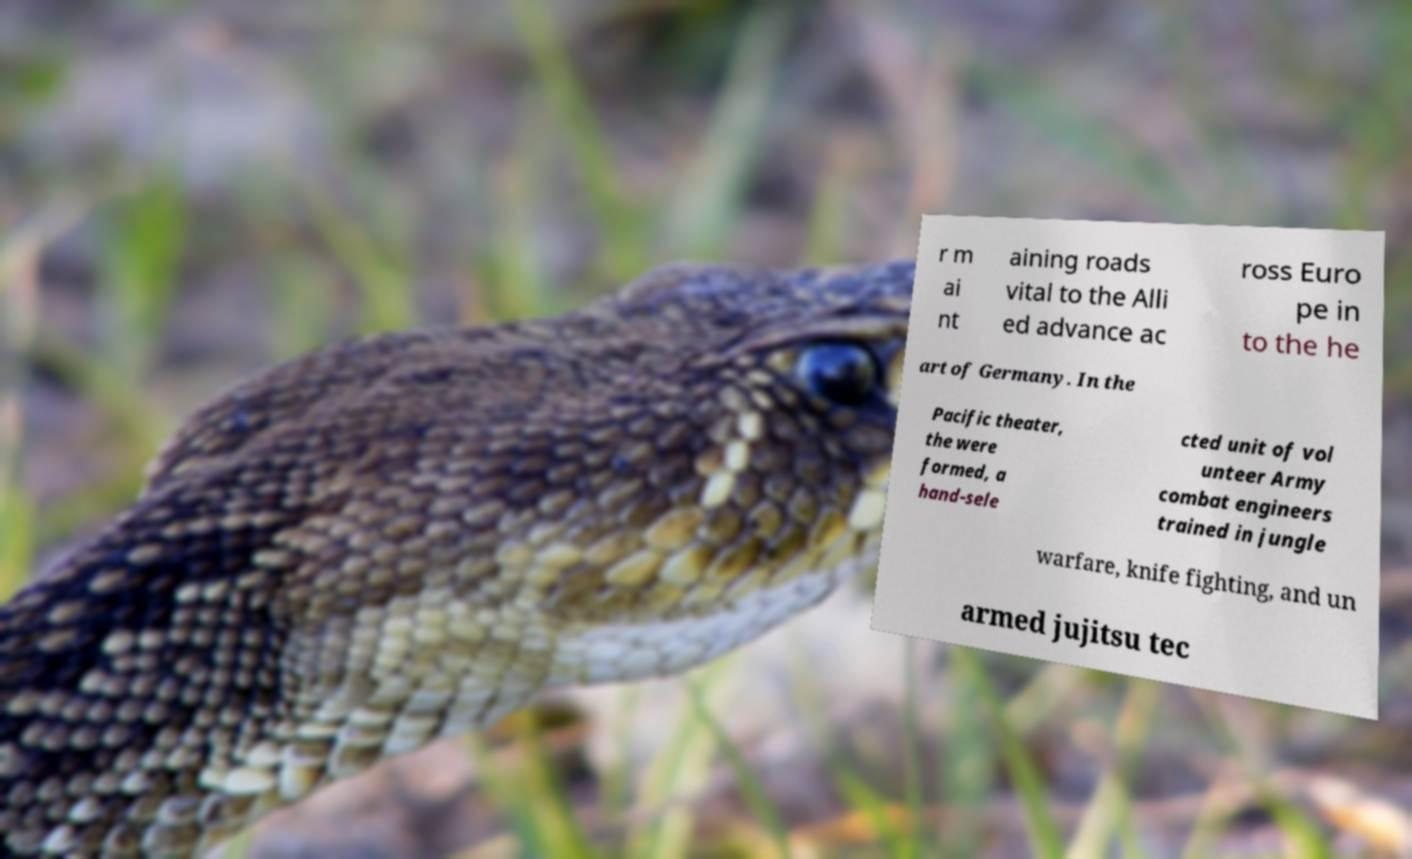Please read and relay the text visible in this image. What does it say? r m ai nt aining roads vital to the Alli ed advance ac ross Euro pe in to the he art of Germany. In the Pacific theater, the were formed, a hand-sele cted unit of vol unteer Army combat engineers trained in jungle warfare, knife fighting, and un armed jujitsu tec 